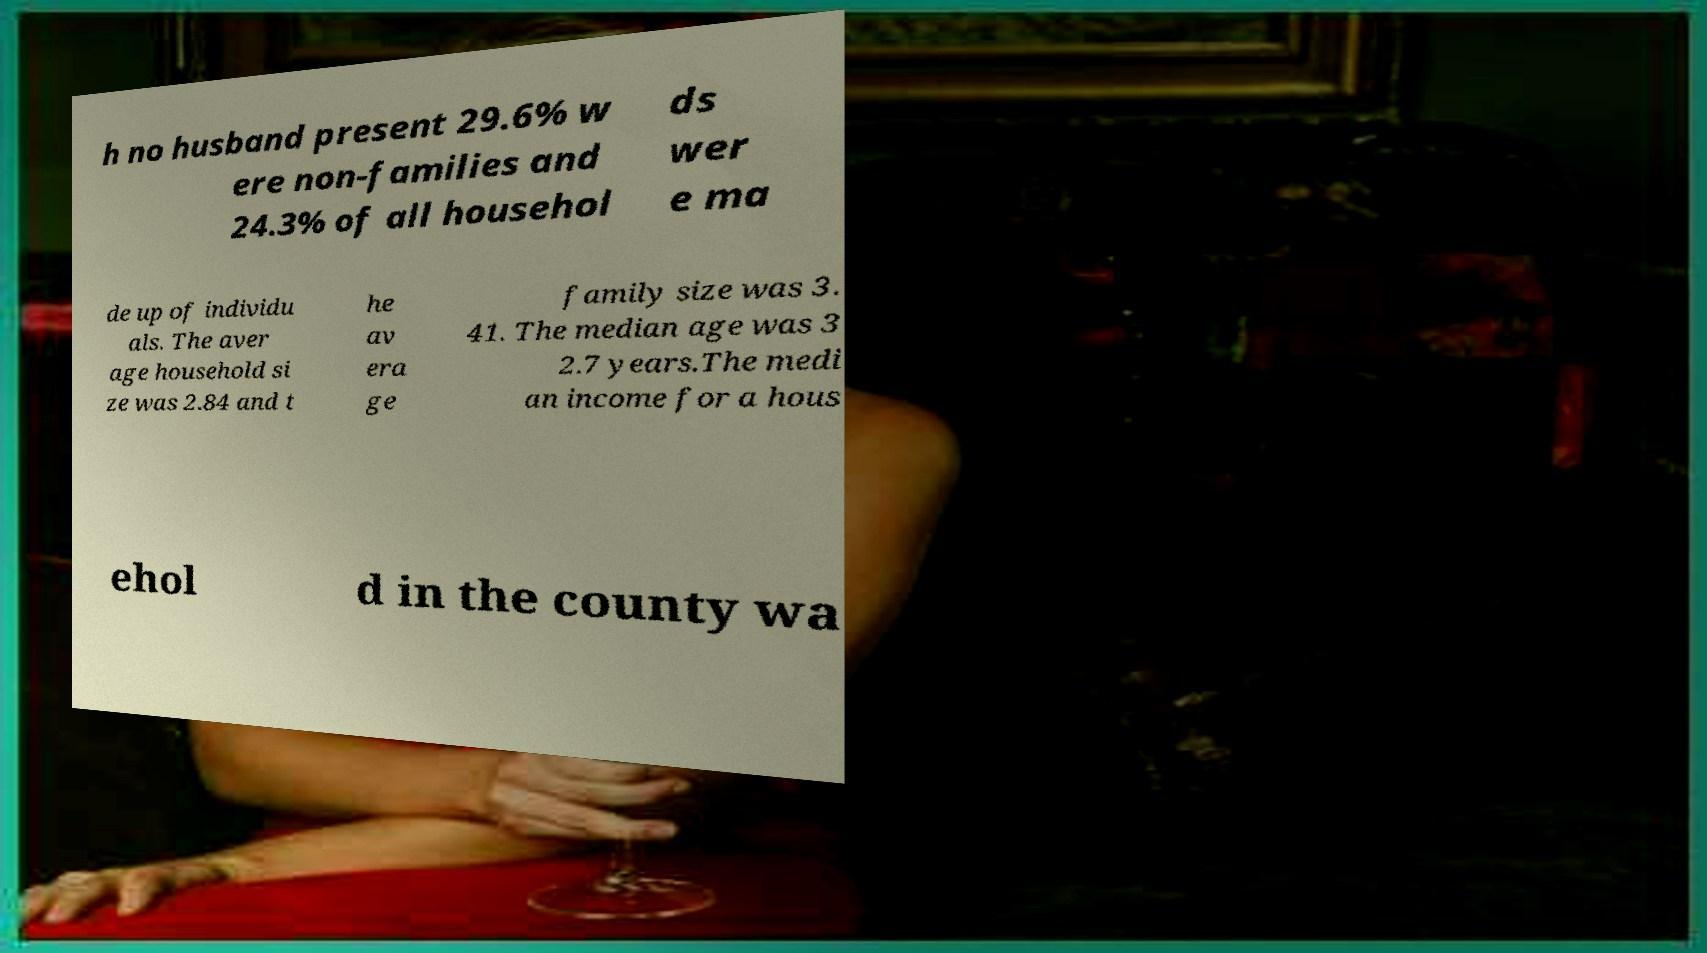There's text embedded in this image that I need extracted. Can you transcribe it verbatim? h no husband present 29.6% w ere non-families and 24.3% of all househol ds wer e ma de up of individu als. The aver age household si ze was 2.84 and t he av era ge family size was 3. 41. The median age was 3 2.7 years.The medi an income for a hous ehol d in the county wa 